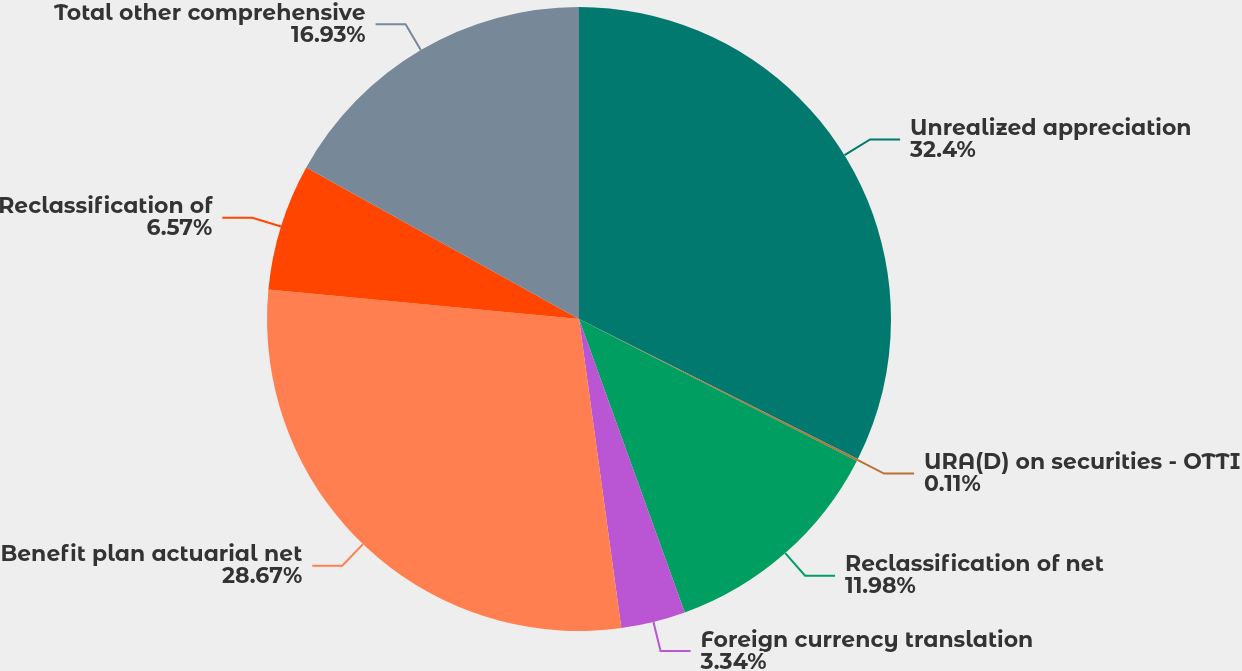<chart> <loc_0><loc_0><loc_500><loc_500><pie_chart><fcel>Unrealized appreciation<fcel>URA(D) on securities - OTTI<fcel>Reclassification of net<fcel>Foreign currency translation<fcel>Benefit plan actuarial net<fcel>Reclassification of<fcel>Total other comprehensive<nl><fcel>32.41%<fcel>0.11%<fcel>11.98%<fcel>3.34%<fcel>28.67%<fcel>6.57%<fcel>16.93%<nl></chart> 